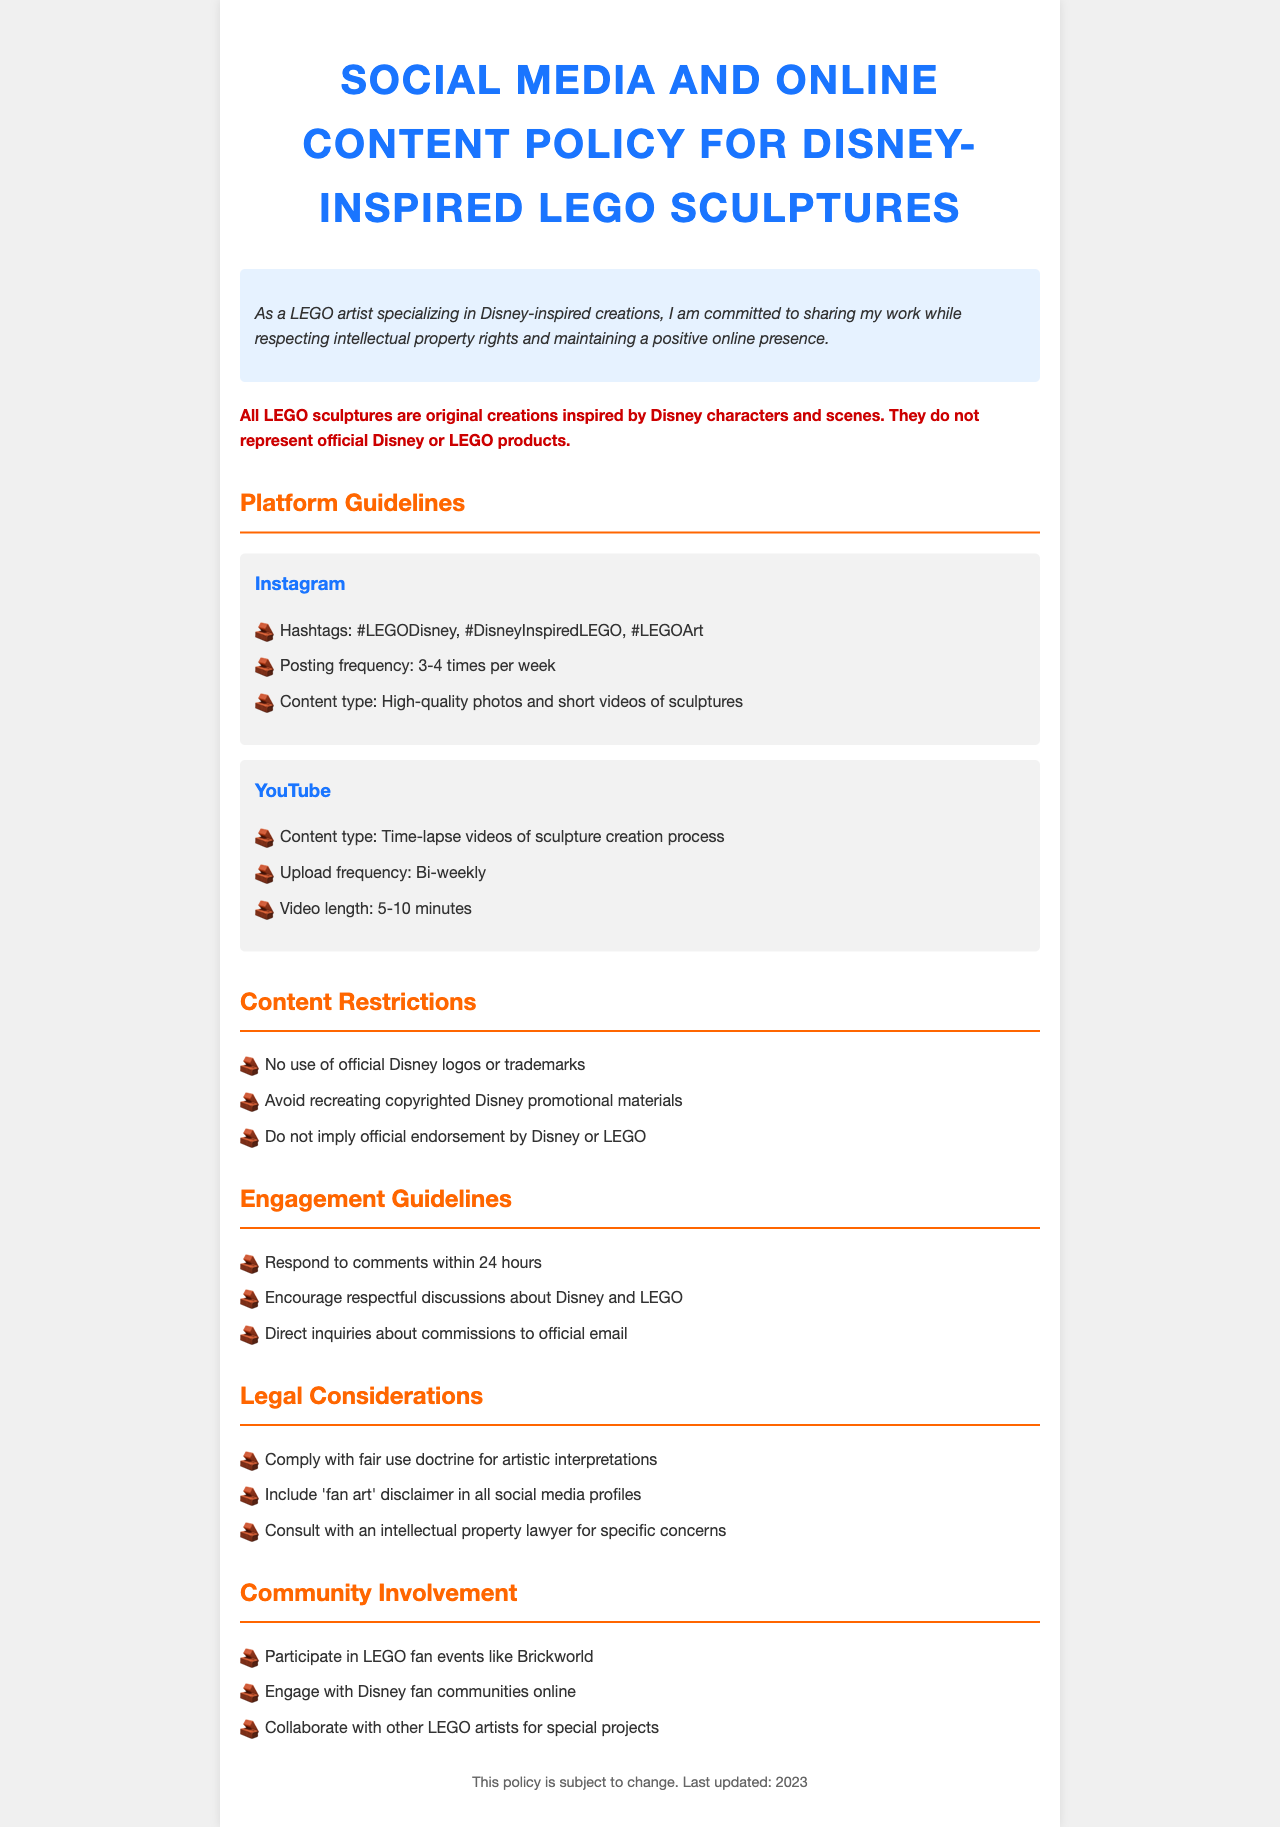What is the posting frequency for Instagram? The document states the posting frequency for Instagram as 3-4 times per week.
Answer: 3-4 times per week What is the content type recommended for YouTube? The document recommends time-lapse videos of the sculpture creation process as the content type for YouTube.
Answer: Time-lapse videos What is the disclaimer mentioned in the document? The disclaimer clarifies that all sculptures are original creations inspired by Disney and do not represent official products.
Answer: All LEGO sculptures are original creations inspired by Disney characters and scenes How often should videos be uploaded to YouTube? The document specifies that videos should be uploaded bi-weekly.
Answer: Bi-weekly What is one prohibition listed under content restrictions? The document lists that no use of official Disney logos or trademarks is allowed.
Answer: No use of official Disney logos or trademarks What is the recommendation for engaging with comments? The document suggests responding to comments within 24 hours.
Answer: Respond to comments within 24 hours What type of events should the artist participate in? The document states the artist should participate in LEGO fan events like Brickworld.
Answer: LEGO fan events like Brickworld What should be included in social media profiles? The document advises to include a 'fan art' disclaimer in all social media profiles.
Answer: 'Fan art' disclaimer 